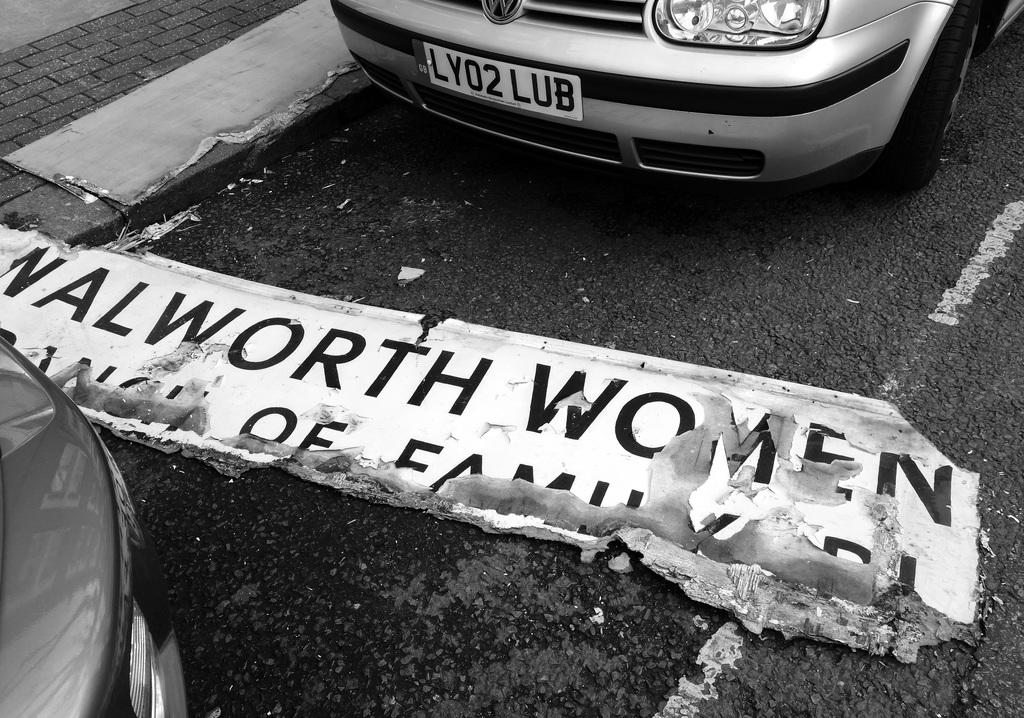Provide a one-sentence caption for the provided image. Sign in front of a car for walworth woman on the roaed. 